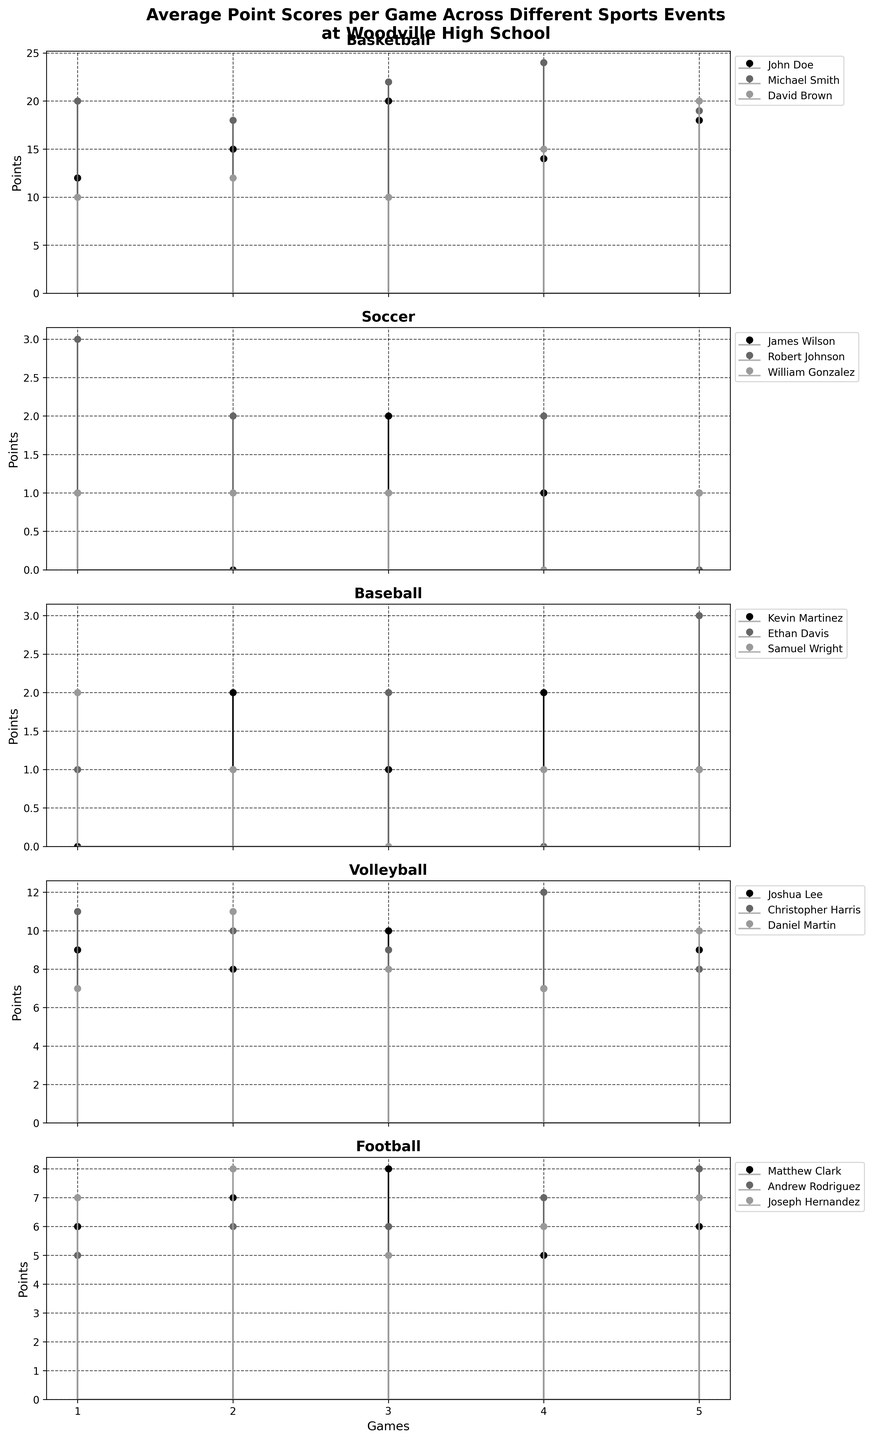What is the title of the figure? The title is usually displayed at the top of the figure. In this case, it is indicated in the code definition.
Answer: Average Point Scores per Game Across Different Sports Events at Woodville High School How many sports are represented in the figure? Each subplot represents a different sport, which can be counted from the subplot titles. According to the data, we have Basketball, Soccer, Baseball, Volleyball, and Football.
Answer: 5 Which sport has the highest average points per game for any player in a single game? To find this, look at each subplot and identify the player with the highest points in a single game. Michael Smith from Basketball has scores of 20, 18, 22, 24, 19, with the highest being 24.
Answer: Basketball What is the average score across all games for David Brown in Basketball? David Brown's scores in the games are 10, 12, 10, 15, 20. Average = (10+12+10+15+20)/5 = 67/5
Answer: 13.4 Which Volleyball player scored the least points in Game 4? Check the Volleyball subplot and look at the points for Game 4. Joshua Lee scored 7, Christopher Harris scored 12, and Daniel Martin scored 7. The lowest is 7, and both Joshua Lee and Daniel Martin have it.
Answer: Joshua Lee and Daniel Martin In Soccer, compare the total points scored by James Wilson and Robert Johnson. Who scored more? Summing up their scores: James Wilson: 1+0+2+1+1 = 5, Robert Johnson: 3+2+1+2+0 = 8. Therefore, Robert Johnson scored more.
Answer: Robert Johnson What are the points scored by Matthew Clark in Football across all games? Refer to the subplot for Football and note the points: 6, 7, 8, 5, 6.
Answer: 6, 7, 8, 5, 6 Which sport has the most uniform scoring (least variability) among players? The sport with the least variability can be determined by visually inspecting the plots and looking for the sport where the players' scores are most consistent across games. Volleyball seems uniform across players and games.
Answer: Volleyball Which Baseball player had the highest score in Game 5 and what was the score? Check the Baseball subplot for Game 5. Kevin Martinez scored 1, Ethan Davis scored 3, and Samuel Wright scored 1. The highest score is 3 by Ethan Davis.
Answer: Ethan Davis, 3 